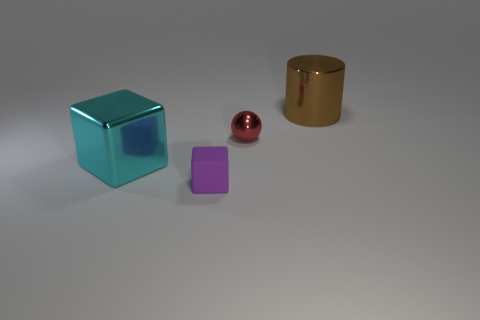Add 2 small green shiny objects. How many objects exist? 6 Subtract all cylinders. How many objects are left? 3 Add 3 large shiny cylinders. How many large shiny cylinders are left? 4 Add 4 cyan cubes. How many cyan cubes exist? 5 Subtract 0 red cylinders. How many objects are left? 4 Subtract all blocks. Subtract all tiny yellow metallic things. How many objects are left? 2 